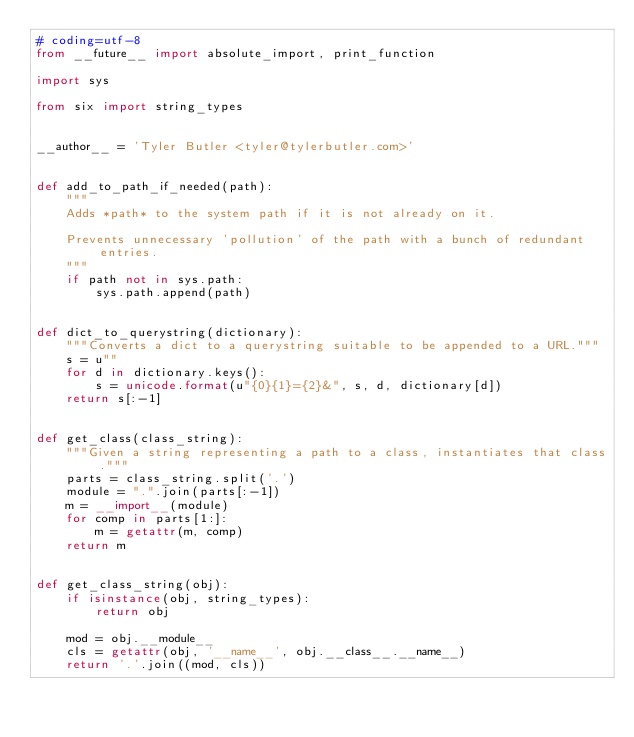Convert code to text. <code><loc_0><loc_0><loc_500><loc_500><_Python_># coding=utf-8
from __future__ import absolute_import, print_function

import sys

from six import string_types


__author__ = 'Tyler Butler <tyler@tylerbutler.com>'


def add_to_path_if_needed(path):
    """
    Adds *path* to the system path if it is not already on it.

    Prevents unnecessary 'pollution' of the path with a bunch of redundant entries.
    """
    if path not in sys.path:
        sys.path.append(path)


def dict_to_querystring(dictionary):
    """Converts a dict to a querystring suitable to be appended to a URL."""
    s = u""
    for d in dictionary.keys():
        s = unicode.format(u"{0}{1}={2}&", s, d, dictionary[d])
    return s[:-1]


def get_class(class_string):
    """Given a string representing a path to a class, instantiates that class."""
    parts = class_string.split('.')
    module = ".".join(parts[:-1])
    m = __import__(module)
    for comp in parts[1:]:
        m = getattr(m, comp)
    return m


def get_class_string(obj):
    if isinstance(obj, string_types):
        return obj

    mod = obj.__module__
    cls = getattr(obj, '__name__', obj.__class__.__name__)
    return '.'.join((mod, cls))
</code> 